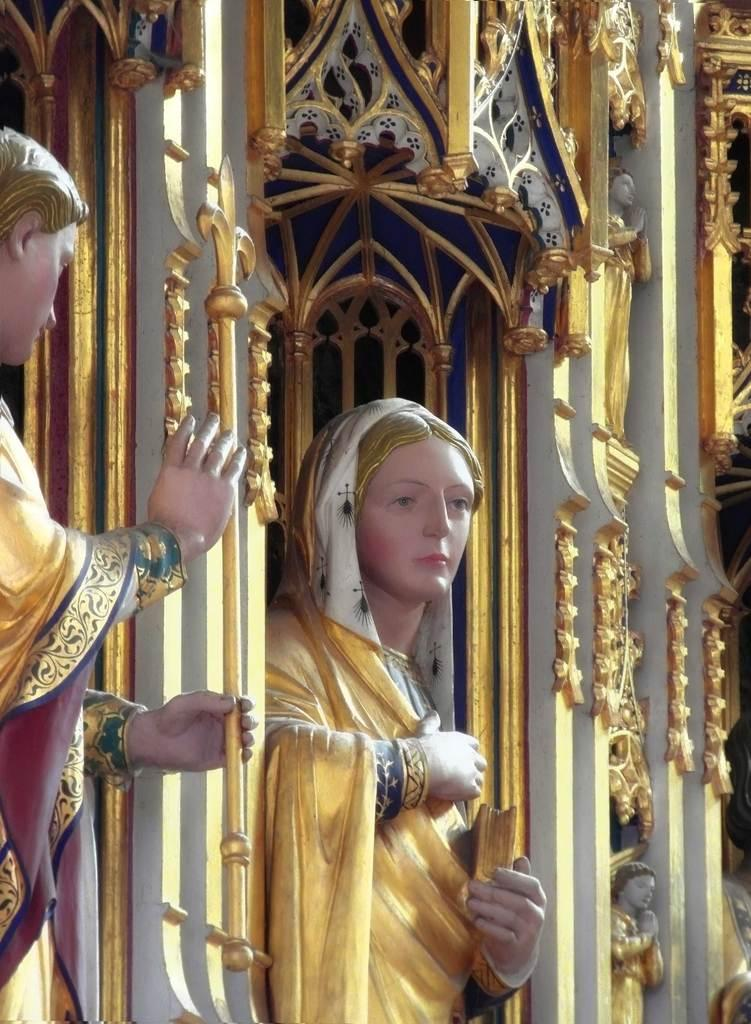What is the main subject of the image? The main subject of the image is idols. Can you describe the background of the image? There is a wall with sculptures in the background. What is the person idol holding in his hand? The person idol is holding a stick in his hand. Is the person idol stuck in quicksand in the image? No, there is no quicksand present in the image. What color is the orange in the image? There is no orange present in the image. 